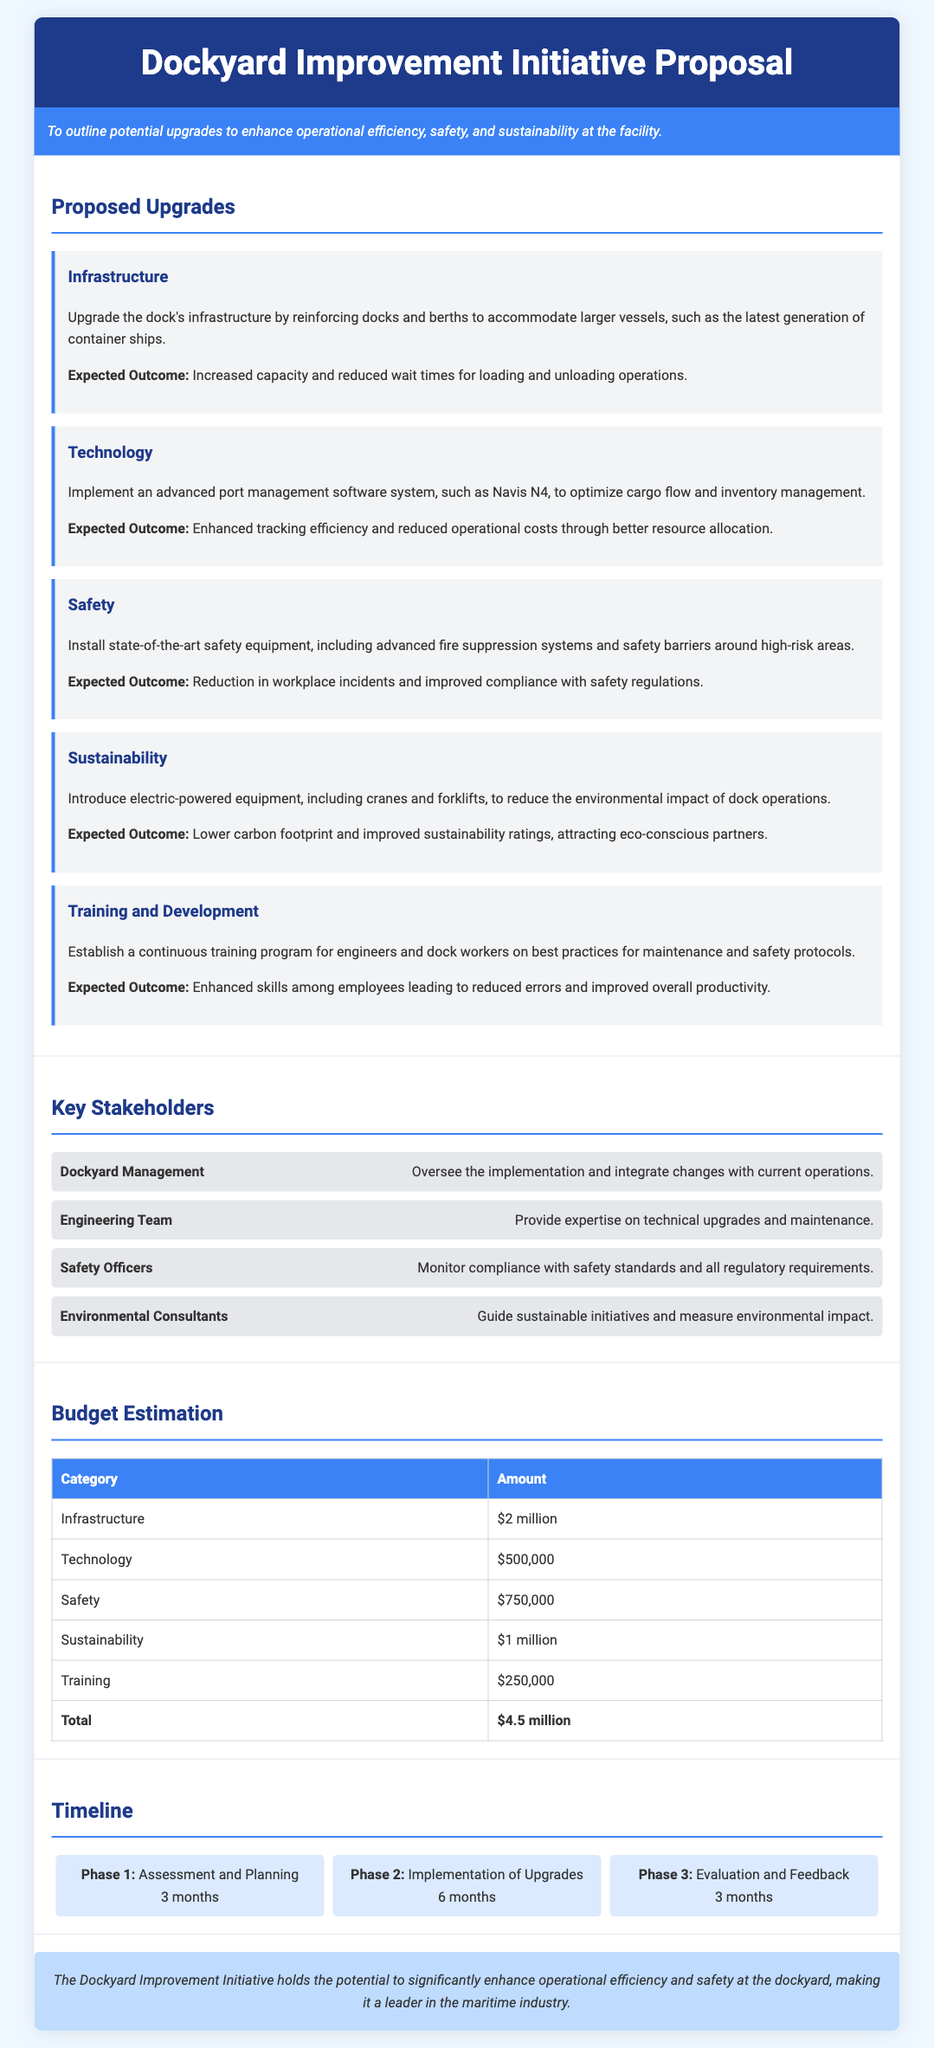What is the main objective of the proposal? The objective is to outline potential upgrades to enhance operational efficiency, safety, and sustainability at the facility.
Answer: Enhance operational efficiency, safety, and sustainability How much is allocated for infrastructure upgrades? The budget estimation for infrastructure upgrades is specified in the budget table located in the document.
Answer: $2 million What technology is proposed for implementation? The proposed technology for implementation is mentioned in the upgrades section related to the advanced port management system.
Answer: Navis N4 What is the expected outcome of introducing electric-powered equipment? The expected outcome is stated under the sustainability upgrade section regarding the reduction of environmental impact.
Answer: Lower carbon footprint How many phases are included in the project timeline? The timeline section outlines the different project phases and their count as described in the document.
Answer: 3 phases Who is responsible for monitoring compliance with safety standards? This information is provided in the key stakeholders section, specifying roles of each stakeholder.
Answer: Safety Officers What is the total budget estimation for the Dockyard Improvement Initiative? The total budget can be found at the end of the budget estimation table section.
Answer: $4.5 million What is the duration of Phase 2: Implementation of Upgrades? The duration for this phase is specified in the timeline section of the document detailing each phase's timeframe.
Answer: 6 months What is the expected outcome of the training and development program? This outcome is clearly indicated under the training and development upgrade section discussing employee improvements.
Answer: Enhanced skills among employees 